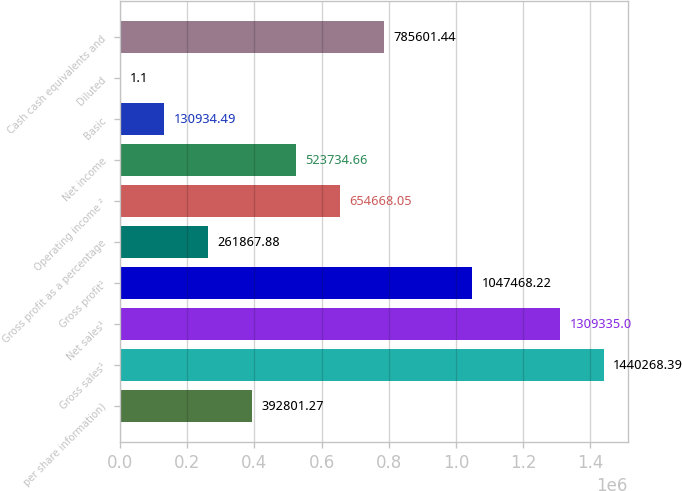<chart> <loc_0><loc_0><loc_500><loc_500><bar_chart><fcel>per share information)<fcel>Gross sales¹<fcel>Net sales¹<fcel>Gross profit¹<fcel>Gross profit as a percentage<fcel>Operating income ²<fcel>Net income<fcel>Basic<fcel>Diluted<fcel>Cash cash equivalents and<nl><fcel>392801<fcel>1.44027e+06<fcel>1.30934e+06<fcel>1.04747e+06<fcel>261868<fcel>654668<fcel>523735<fcel>130934<fcel>1.1<fcel>785601<nl></chart> 